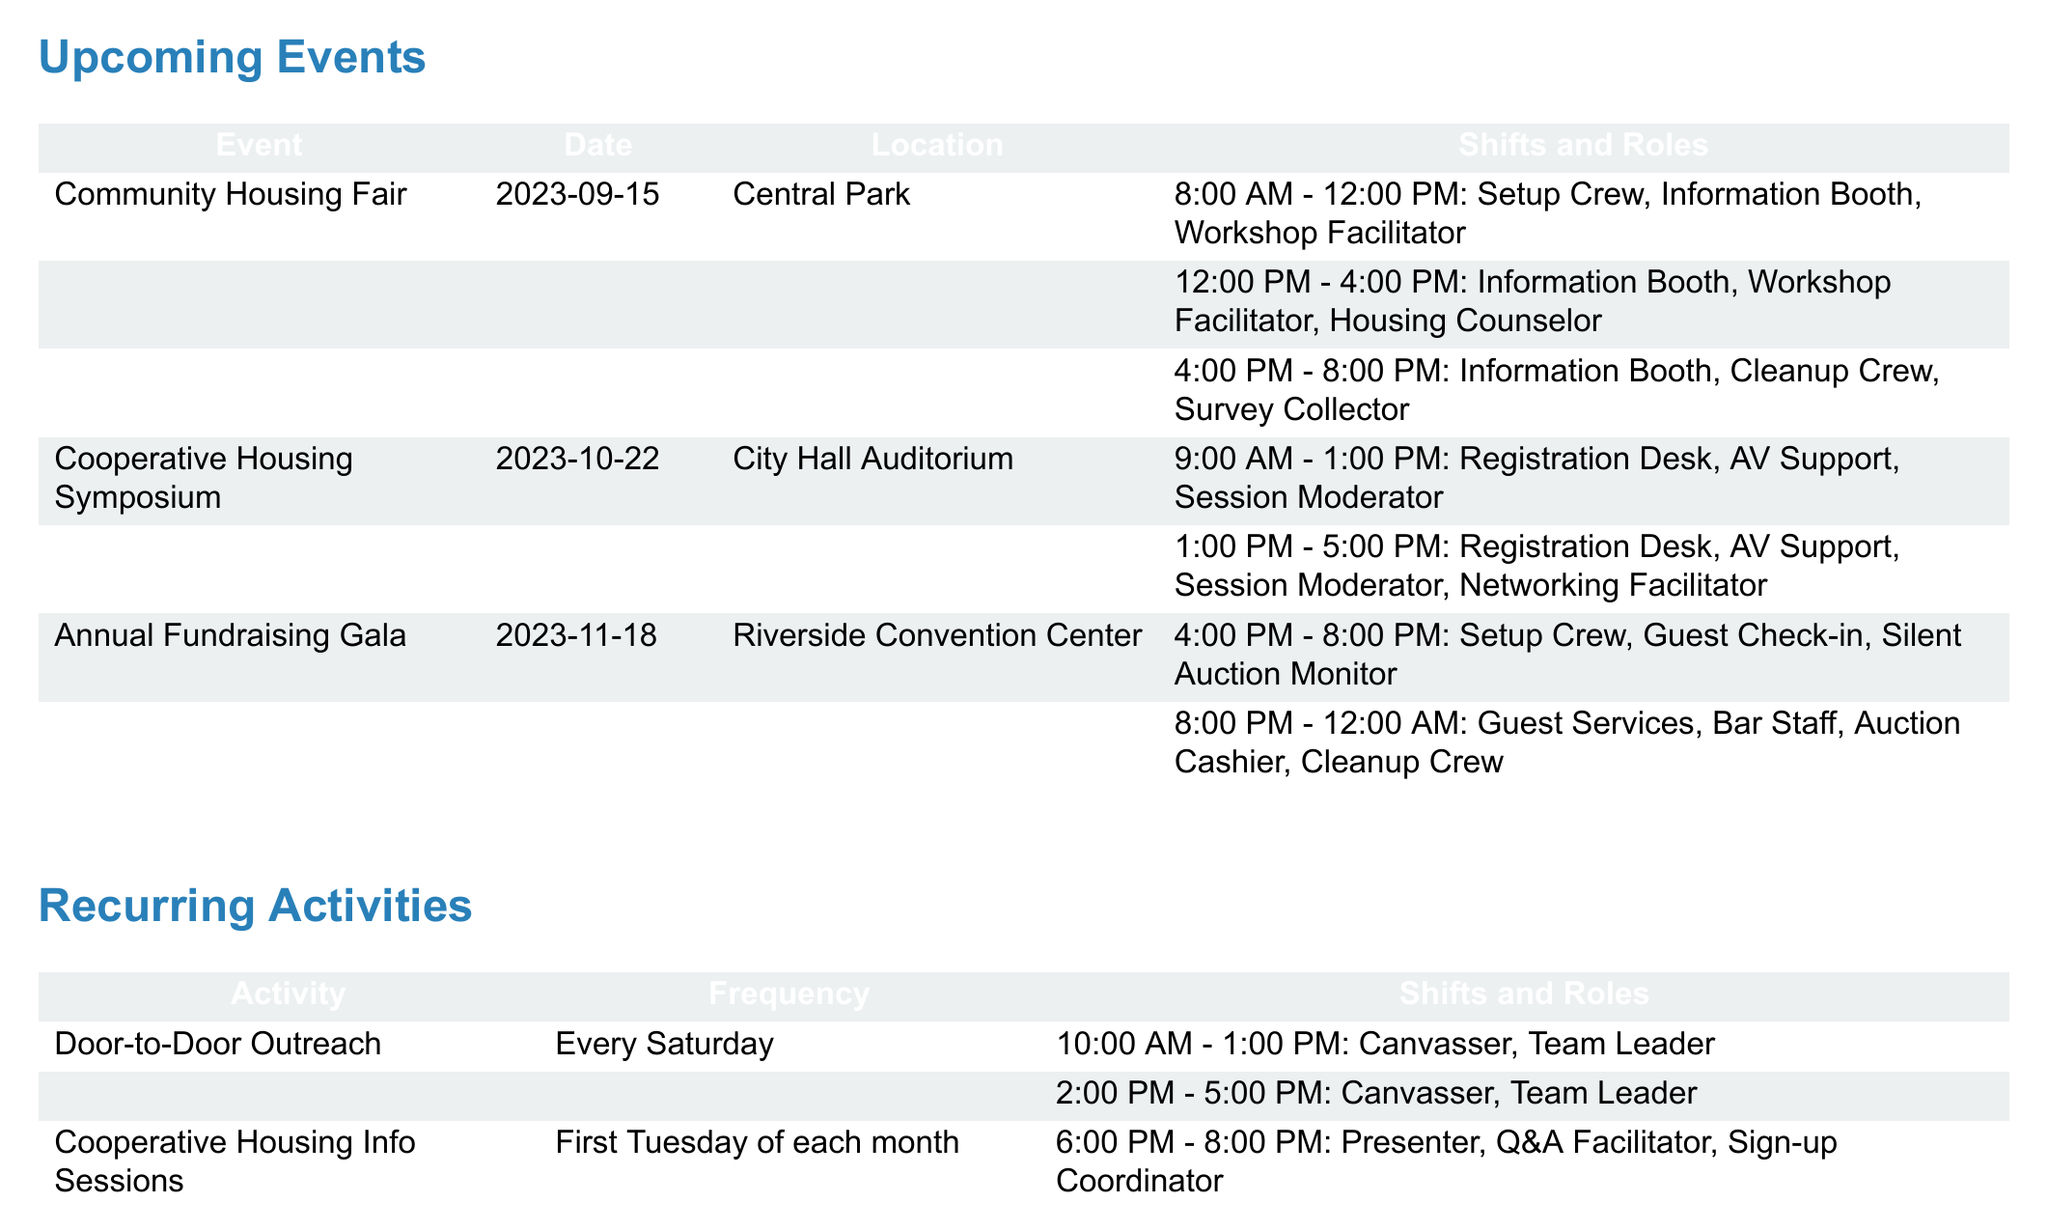what is the date of the Community Housing Fair? The Community Housing Fair is scheduled for September 15, 2023.
Answer: September 15, 2023 how many roles are available during the 8:00 AM - 12:00 PM shift at the Annual Fundraising Gala? The 8:00 AM - 12:00 PM shift at the Annual Fundraising Gala has three roles: Setup Crew, Guest Check-in, and Silent Auction Monitor.
Answer: 3 where is the Cooperative Housing Symposium held? The Cooperative Housing Symposium takes place at City Hall Auditorium.
Answer: City Hall Auditorium what roles are involved in the Door-to-Door Outreach activity? The Door-to-Door Outreach activity involves two roles: Canvasser and Team Leader.
Answer: Canvasser, Team Leader how many shifts are there for the Habitat for Humanity Partnership Build? There are two shifts available for the Habitat for Humanity Partnership Build: one from 8:00 AM to 12:00 PM and another from 1:00 PM to 5:00 PM.
Answer: 2 what is the frequency of the Cooperative Housing Info Sessions? The Cooperative Housing Info Sessions occur on the first Tuesday of each month.
Answer: First Tuesday of each month which event has a shift ending at 8:00 PM? The Annual Fundraising Gala has a shift that ends at 8:00 PM.
Answer: Annual Fundraising Gala how long will the Community Land Trust Workshop Series run? The Community Land Trust Workshop Series runs from September 5, 2023, to October 24, 2023.
Answer: September 5, 2023, to October 24, 2023 